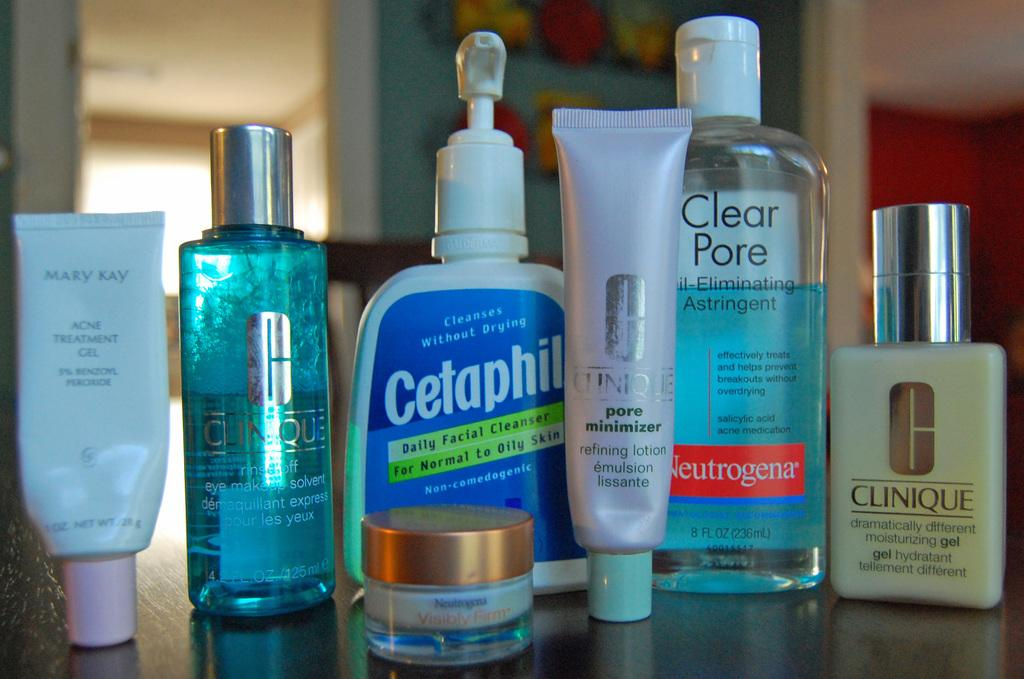<image>
Offer a succinct explanation of the picture presented. several jars and bottles for things like Clinique and Cetaphil 